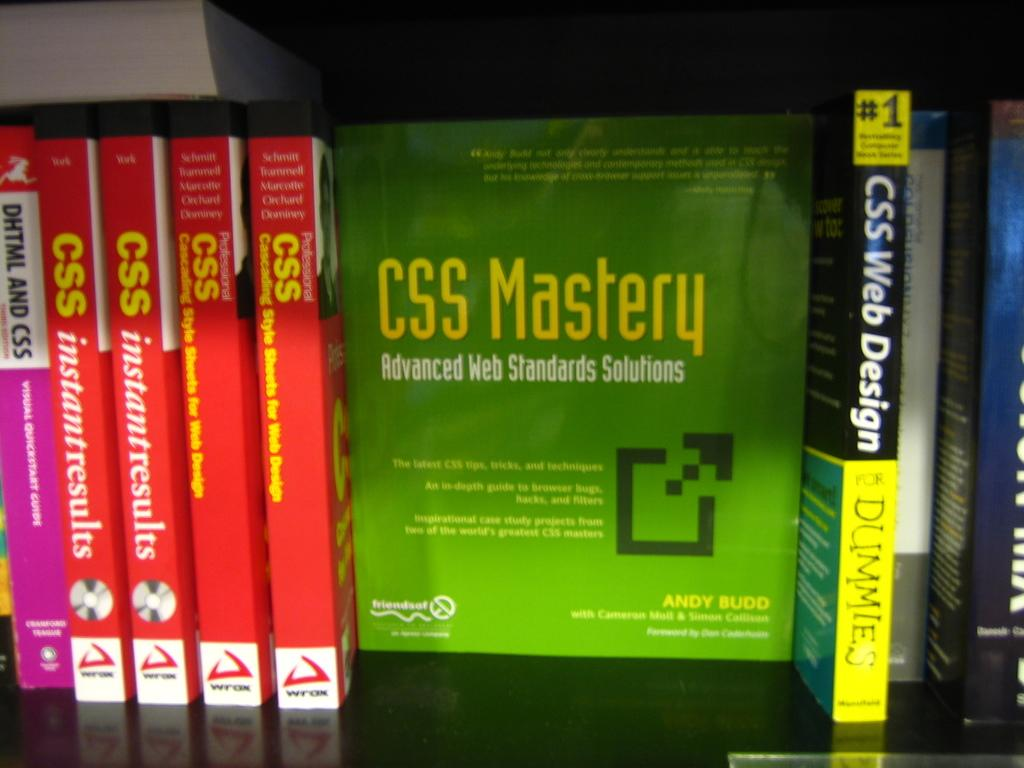<image>
Give a short and clear explanation of the subsequent image. books next to one another with one of them titled 'css web design for dummies' 